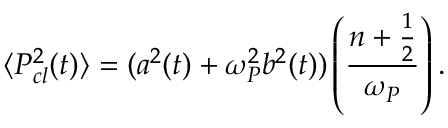Convert formula to latex. <formula><loc_0><loc_0><loc_500><loc_500>\langle P _ { c l } ^ { 2 } ( t ) \rangle = ( a ^ { 2 } ( t ) + \omega _ { P } ^ { 2 } b ^ { 2 } ( t ) ) \left ( \frac { n + \frac { 1 } { 2 } } { \omega _ { P } } \right ) .</formula> 